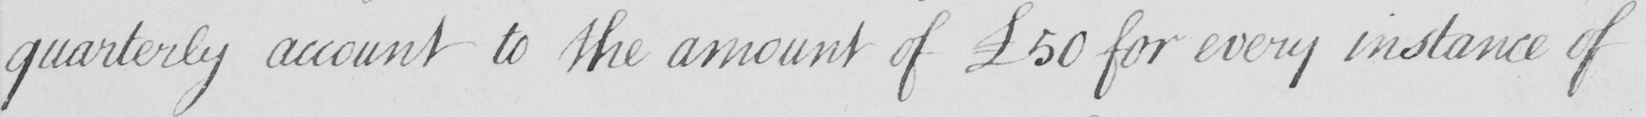What does this handwritten line say? quarterly account to the amount of £50 for every instance of 